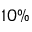Convert formula to latex. <formula><loc_0><loc_0><loc_500><loc_500>1 0 \%</formula> 